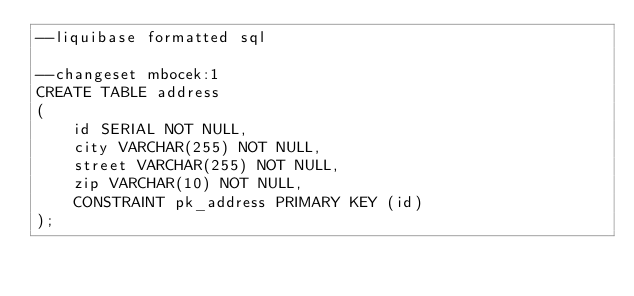Convert code to text. <code><loc_0><loc_0><loc_500><loc_500><_SQL_>--liquibase formatted sql

--changeset mbocek:1
CREATE TABLE address
(
    id SERIAL NOT NULL,
    city VARCHAR(255) NOT NULL,
    street VARCHAR(255) NOT NULL,
    zip VARCHAR(10) NOT NULL,
    CONSTRAINT pk_address PRIMARY KEY (id)
);
</code> 